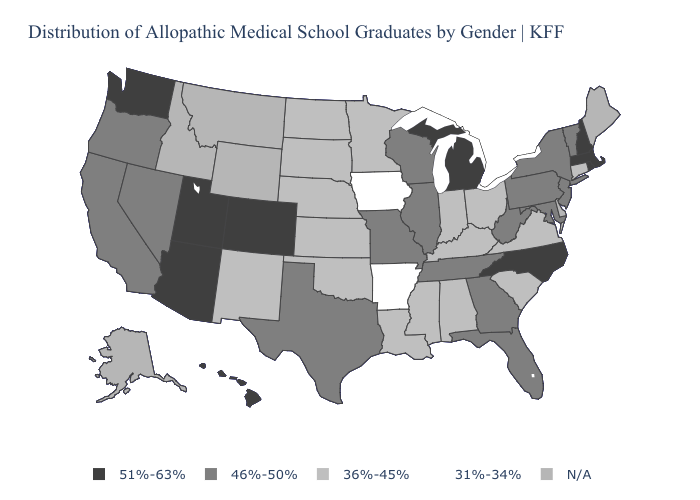What is the value of Indiana?
Answer briefly. 36%-45%. Name the states that have a value in the range 51%-63%?
Answer briefly. Arizona, Colorado, Hawaii, Massachusetts, Michigan, New Hampshire, North Carolina, Rhode Island, Utah, Washington. Name the states that have a value in the range 31%-34%?
Give a very brief answer. Arkansas, Iowa. Among the states that border Minnesota , which have the highest value?
Concise answer only. Wisconsin. Name the states that have a value in the range 46%-50%?
Concise answer only. California, Florida, Georgia, Illinois, Maryland, Missouri, Nevada, New Jersey, New York, Oregon, Pennsylvania, Tennessee, Texas, Vermont, West Virginia, Wisconsin. What is the highest value in the Northeast ?
Quick response, please. 51%-63%. Among the states that border Kentucky , which have the lowest value?
Concise answer only. Indiana, Ohio, Virginia. Among the states that border California , which have the highest value?
Concise answer only. Arizona. Name the states that have a value in the range N/A?
Answer briefly. Alaska, Delaware, Idaho, Maine, Montana, Wyoming. Name the states that have a value in the range 31%-34%?
Short answer required. Arkansas, Iowa. What is the highest value in the USA?
Give a very brief answer. 51%-63%. What is the highest value in the MidWest ?
Be succinct. 51%-63%. What is the value of Washington?
Quick response, please. 51%-63%. What is the value of Missouri?
Answer briefly. 46%-50%. Does Connecticut have the lowest value in the Northeast?
Keep it brief. Yes. 